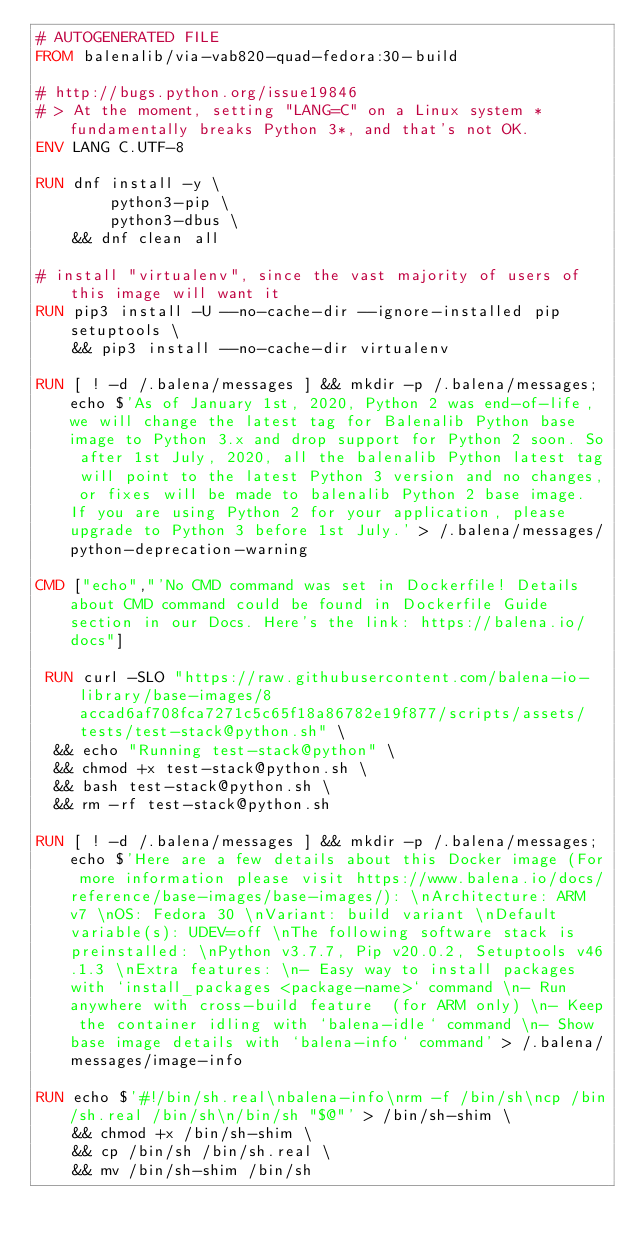Convert code to text. <code><loc_0><loc_0><loc_500><loc_500><_Dockerfile_># AUTOGENERATED FILE
FROM balenalib/via-vab820-quad-fedora:30-build

# http://bugs.python.org/issue19846
# > At the moment, setting "LANG=C" on a Linux system *fundamentally breaks Python 3*, and that's not OK.
ENV LANG C.UTF-8

RUN dnf install -y \
		python3-pip \
		python3-dbus \
	&& dnf clean all

# install "virtualenv", since the vast majority of users of this image will want it
RUN pip3 install -U --no-cache-dir --ignore-installed pip setuptools \
	&& pip3 install --no-cache-dir virtualenv

RUN [ ! -d /.balena/messages ] && mkdir -p /.balena/messages; echo $'As of January 1st, 2020, Python 2 was end-of-life, we will change the latest tag for Balenalib Python base image to Python 3.x and drop support for Python 2 soon. So after 1st July, 2020, all the balenalib Python latest tag will point to the latest Python 3 version and no changes, or fixes will be made to balenalib Python 2 base image. If you are using Python 2 for your application, please upgrade to Python 3 before 1st July.' > /.balena/messages/python-deprecation-warning

CMD ["echo","'No CMD command was set in Dockerfile! Details about CMD command could be found in Dockerfile Guide section in our Docs. Here's the link: https://balena.io/docs"]

 RUN curl -SLO "https://raw.githubusercontent.com/balena-io-library/base-images/8accad6af708fca7271c5c65f18a86782e19f877/scripts/assets/tests/test-stack@python.sh" \
  && echo "Running test-stack@python" \
  && chmod +x test-stack@python.sh \
  && bash test-stack@python.sh \
  && rm -rf test-stack@python.sh 

RUN [ ! -d /.balena/messages ] && mkdir -p /.balena/messages; echo $'Here are a few details about this Docker image (For more information please visit https://www.balena.io/docs/reference/base-images/base-images/): \nArchitecture: ARM v7 \nOS: Fedora 30 \nVariant: build variant \nDefault variable(s): UDEV=off \nThe following software stack is preinstalled: \nPython v3.7.7, Pip v20.0.2, Setuptools v46.1.3 \nExtra features: \n- Easy way to install packages with `install_packages <package-name>` command \n- Run anywhere with cross-build feature  (for ARM only) \n- Keep the container idling with `balena-idle` command \n- Show base image details with `balena-info` command' > /.balena/messages/image-info

RUN echo $'#!/bin/sh.real\nbalena-info\nrm -f /bin/sh\ncp /bin/sh.real /bin/sh\n/bin/sh "$@"' > /bin/sh-shim \
	&& chmod +x /bin/sh-shim \
	&& cp /bin/sh /bin/sh.real \
	&& mv /bin/sh-shim /bin/sh</code> 